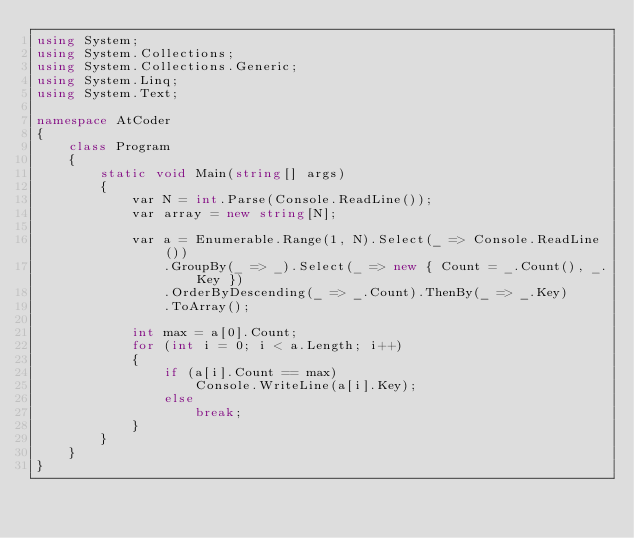<code> <loc_0><loc_0><loc_500><loc_500><_C#_>using System;
using System.Collections;
using System.Collections.Generic;
using System.Linq;
using System.Text;

namespace AtCoder
{
    class Program
    {
        static void Main(string[] args)
        {
            var N = int.Parse(Console.ReadLine());
            var array = new string[N];

            var a = Enumerable.Range(1, N).Select(_ => Console.ReadLine())
                .GroupBy(_ => _).Select(_ => new { Count = _.Count(), _.Key })
                .OrderByDescending(_ => _.Count).ThenBy(_ => _.Key)
                .ToArray();

            int max = a[0].Count;
            for (int i = 0; i < a.Length; i++)
            {
                if (a[i].Count == max)
                    Console.WriteLine(a[i].Key);
                else
                    break;
            }
        }
    }
}
</code> 